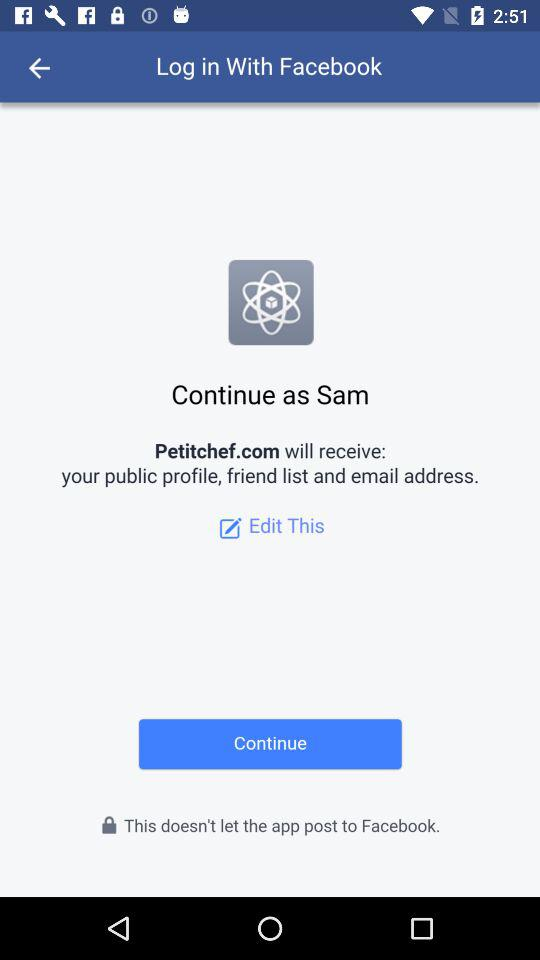Through what application can we log in? You can log in through "Facebook". 